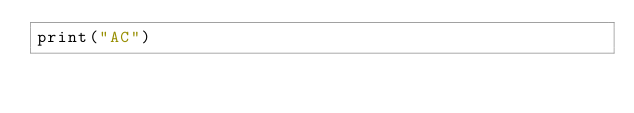<code> <loc_0><loc_0><loc_500><loc_500><_Python_>print("AC")
</code> 